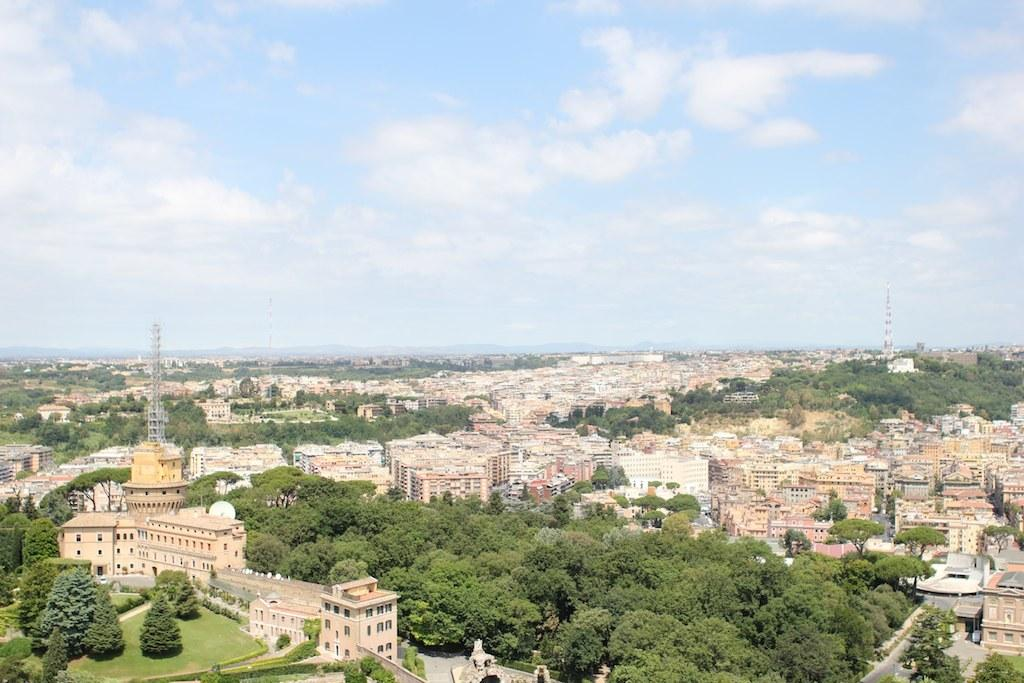What types of structures are present in the image? There are buildings and houses in the image. What natural elements can be seen in the image? There are trees, grass, and plants in the image. What man-made features are visible in the image? There are roads and towers in the image. What part of the natural environment is visible in the background of the image? The sky is visible in the background of the image. Where is the lunchroom located in the image? There is no lunchroom present in the image. What type of precipitation can be seen falling from the sky in the image? There is no precipitation visible in the image; only the sky is visible in the background. 